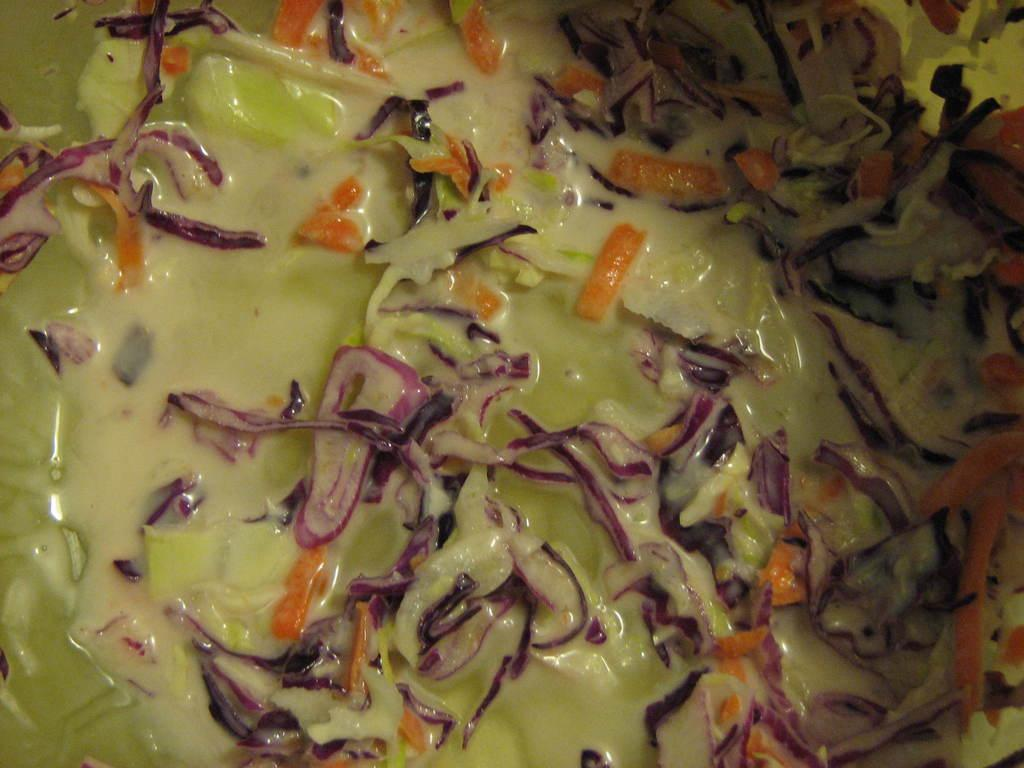What type of food can be seen in the image? The image contains food with cream, green, orange, and white colors. Can you describe the colors of the food in the image? The food has cream, green, orange, and white colors. What type of word is written on the food in the image? There are no words written on the food in the image. Can you see a pencil being used to draw on the food in the image? There is no pencil or drawing present on the food in the image. 